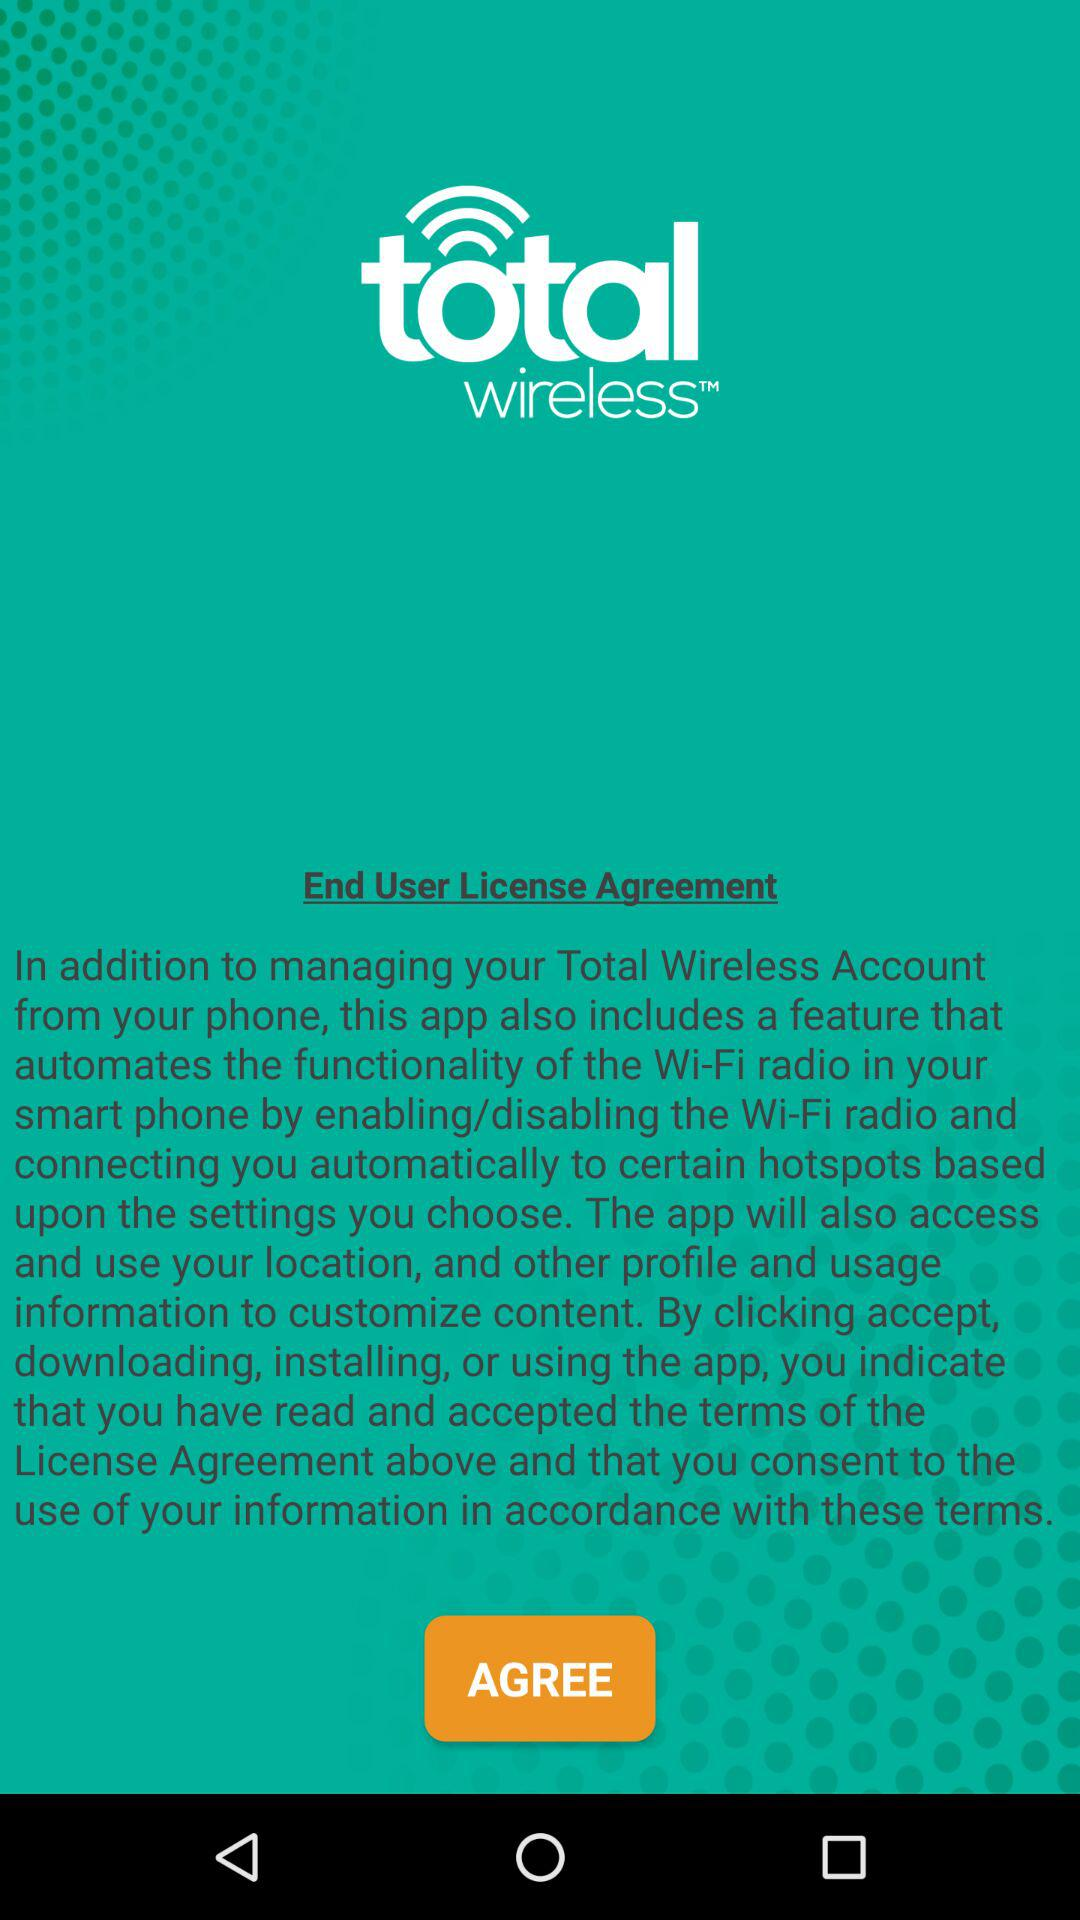What is the app name? The app name is "total wireless". 